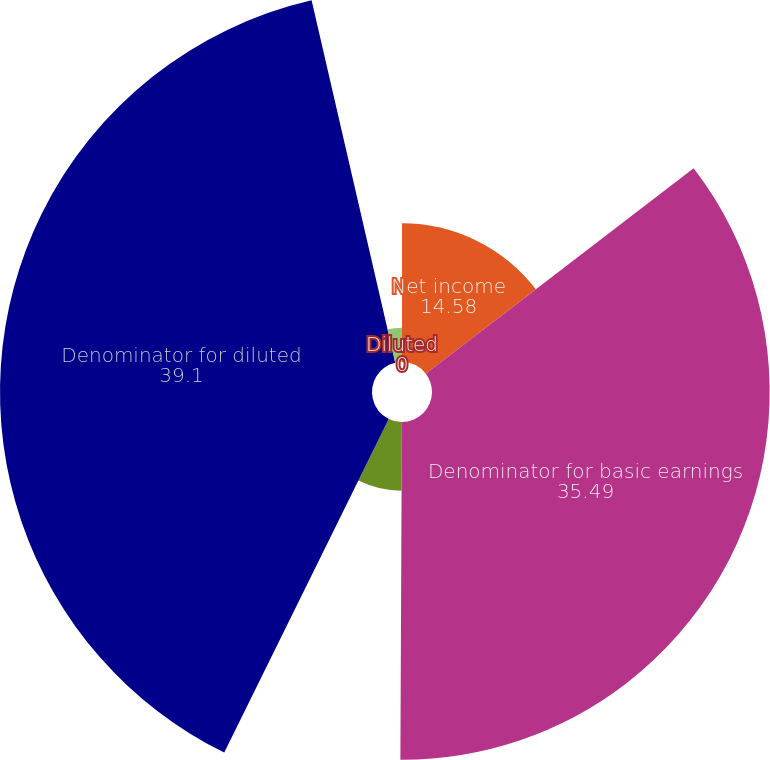Convert chart to OTSL. <chart><loc_0><loc_0><loc_500><loc_500><pie_chart><fcel>Net income<fcel>Denominator for basic earnings<fcel>Stock options RSUs and ESPP<fcel>Denominator for diluted<fcel>Basic<fcel>Diluted<nl><fcel>14.58%<fcel>35.49%<fcel>7.22%<fcel>39.1%<fcel>3.61%<fcel>0.0%<nl></chart> 